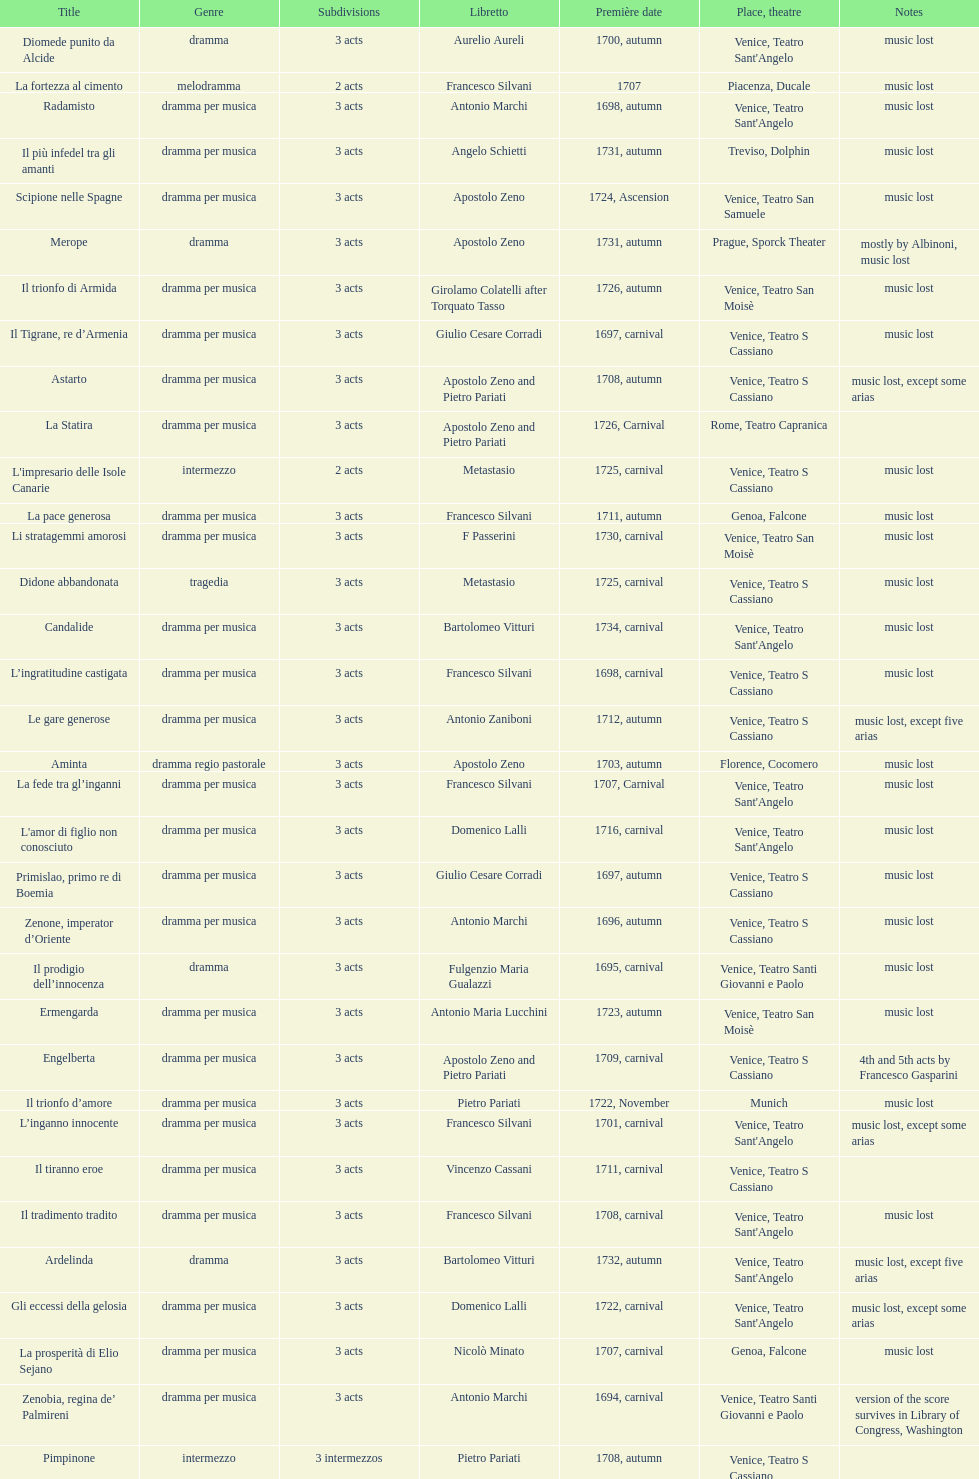Which opera has the most acts, la fortezza al cimento or astarto? Astarto. 